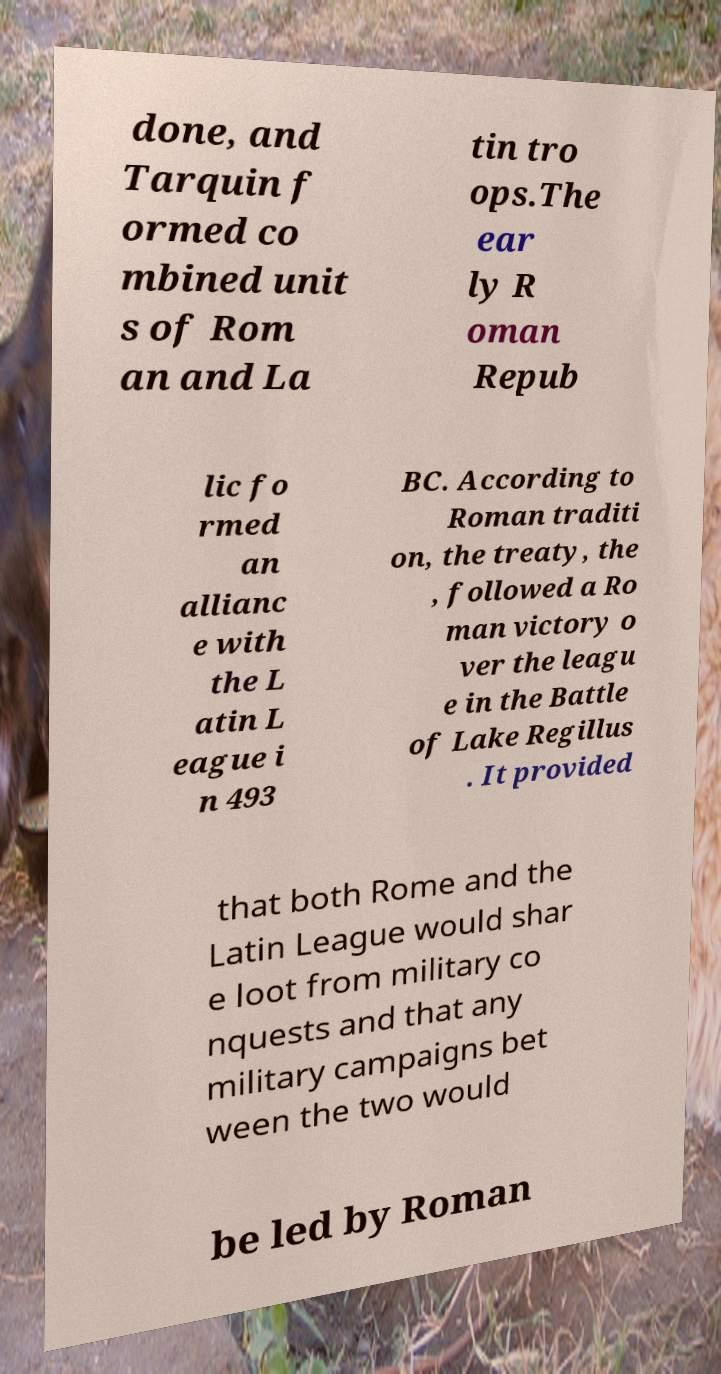For documentation purposes, I need the text within this image transcribed. Could you provide that? done, and Tarquin f ormed co mbined unit s of Rom an and La tin tro ops.The ear ly R oman Repub lic fo rmed an allianc e with the L atin L eague i n 493 BC. According to Roman traditi on, the treaty, the , followed a Ro man victory o ver the leagu e in the Battle of Lake Regillus . It provided that both Rome and the Latin League would shar e loot from military co nquests and that any military campaigns bet ween the two would be led by Roman 